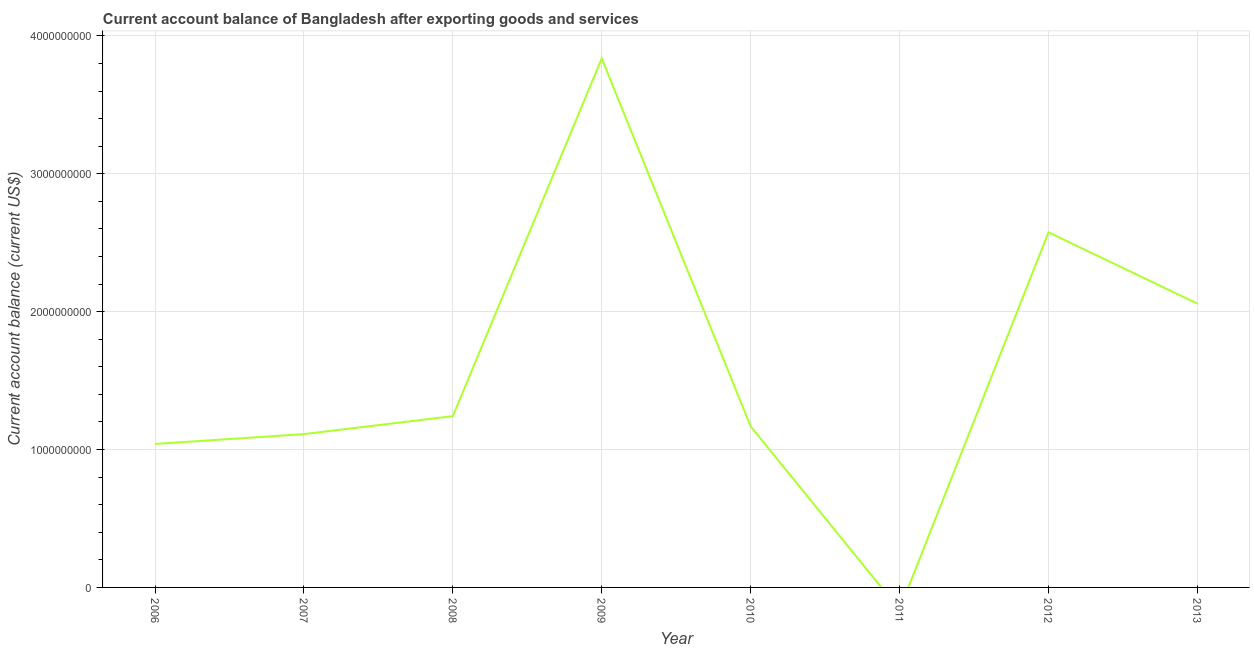What is the current account balance in 2012?
Your answer should be compact. 2.58e+09. Across all years, what is the maximum current account balance?
Offer a very short reply. 3.84e+09. What is the sum of the current account balance?
Your answer should be very brief. 1.30e+1. What is the difference between the current account balance in 2006 and 2009?
Make the answer very short. -2.80e+09. What is the average current account balance per year?
Offer a very short reply. 1.63e+09. What is the median current account balance?
Provide a short and direct response. 1.21e+09. What is the ratio of the current account balance in 2006 to that in 2010?
Your response must be concise. 0.89. What is the difference between the highest and the second highest current account balance?
Provide a short and direct response. 1.26e+09. What is the difference between the highest and the lowest current account balance?
Your answer should be very brief. 3.84e+09. How many lines are there?
Offer a very short reply. 1. Are the values on the major ticks of Y-axis written in scientific E-notation?
Give a very brief answer. No. Does the graph contain grids?
Ensure brevity in your answer.  Yes. What is the title of the graph?
Your answer should be compact. Current account balance of Bangladesh after exporting goods and services. What is the label or title of the X-axis?
Your answer should be very brief. Year. What is the label or title of the Y-axis?
Make the answer very short. Current account balance (current US$). What is the Current account balance (current US$) of 2006?
Keep it short and to the point. 1.04e+09. What is the Current account balance (current US$) in 2007?
Provide a short and direct response. 1.11e+09. What is the Current account balance (current US$) in 2008?
Give a very brief answer. 1.24e+09. What is the Current account balance (current US$) of 2009?
Keep it short and to the point. 3.84e+09. What is the Current account balance (current US$) of 2010?
Ensure brevity in your answer.  1.17e+09. What is the Current account balance (current US$) of 2011?
Make the answer very short. 0. What is the Current account balance (current US$) in 2012?
Keep it short and to the point. 2.58e+09. What is the Current account balance (current US$) in 2013?
Your answer should be compact. 2.06e+09. What is the difference between the Current account balance (current US$) in 2006 and 2007?
Your response must be concise. -7.13e+07. What is the difference between the Current account balance (current US$) in 2006 and 2008?
Give a very brief answer. -2.02e+08. What is the difference between the Current account balance (current US$) in 2006 and 2009?
Give a very brief answer. -2.80e+09. What is the difference between the Current account balance (current US$) in 2006 and 2010?
Provide a succinct answer. -1.27e+08. What is the difference between the Current account balance (current US$) in 2006 and 2012?
Offer a very short reply. -1.53e+09. What is the difference between the Current account balance (current US$) in 2006 and 2013?
Offer a terse response. -1.02e+09. What is the difference between the Current account balance (current US$) in 2007 and 2008?
Keep it short and to the point. -1.30e+08. What is the difference between the Current account balance (current US$) in 2007 and 2009?
Ensure brevity in your answer.  -2.72e+09. What is the difference between the Current account balance (current US$) in 2007 and 2010?
Provide a succinct answer. -5.61e+07. What is the difference between the Current account balance (current US$) in 2007 and 2012?
Offer a very short reply. -1.46e+09. What is the difference between the Current account balance (current US$) in 2007 and 2013?
Give a very brief answer. -9.47e+08. What is the difference between the Current account balance (current US$) in 2008 and 2009?
Make the answer very short. -2.59e+09. What is the difference between the Current account balance (current US$) in 2008 and 2010?
Ensure brevity in your answer.  7.42e+07. What is the difference between the Current account balance (current US$) in 2008 and 2012?
Your answer should be very brief. -1.33e+09. What is the difference between the Current account balance (current US$) in 2008 and 2013?
Give a very brief answer. -8.16e+08. What is the difference between the Current account balance (current US$) in 2009 and 2010?
Give a very brief answer. 2.67e+09. What is the difference between the Current account balance (current US$) in 2009 and 2012?
Offer a terse response. 1.26e+09. What is the difference between the Current account balance (current US$) in 2009 and 2013?
Provide a succinct answer. 1.78e+09. What is the difference between the Current account balance (current US$) in 2010 and 2012?
Make the answer very short. -1.41e+09. What is the difference between the Current account balance (current US$) in 2010 and 2013?
Your answer should be very brief. -8.90e+08. What is the difference between the Current account balance (current US$) in 2012 and 2013?
Give a very brief answer. 5.17e+08. What is the ratio of the Current account balance (current US$) in 2006 to that in 2007?
Keep it short and to the point. 0.94. What is the ratio of the Current account balance (current US$) in 2006 to that in 2008?
Your answer should be very brief. 0.84. What is the ratio of the Current account balance (current US$) in 2006 to that in 2009?
Keep it short and to the point. 0.27. What is the ratio of the Current account balance (current US$) in 2006 to that in 2010?
Give a very brief answer. 0.89. What is the ratio of the Current account balance (current US$) in 2006 to that in 2012?
Your response must be concise. 0.4. What is the ratio of the Current account balance (current US$) in 2006 to that in 2013?
Offer a very short reply. 0.51. What is the ratio of the Current account balance (current US$) in 2007 to that in 2008?
Give a very brief answer. 0.9. What is the ratio of the Current account balance (current US$) in 2007 to that in 2009?
Keep it short and to the point. 0.29. What is the ratio of the Current account balance (current US$) in 2007 to that in 2010?
Give a very brief answer. 0.95. What is the ratio of the Current account balance (current US$) in 2007 to that in 2012?
Your answer should be compact. 0.43. What is the ratio of the Current account balance (current US$) in 2007 to that in 2013?
Keep it short and to the point. 0.54. What is the ratio of the Current account balance (current US$) in 2008 to that in 2009?
Your answer should be compact. 0.32. What is the ratio of the Current account balance (current US$) in 2008 to that in 2010?
Give a very brief answer. 1.06. What is the ratio of the Current account balance (current US$) in 2008 to that in 2012?
Ensure brevity in your answer.  0.48. What is the ratio of the Current account balance (current US$) in 2008 to that in 2013?
Give a very brief answer. 0.6. What is the ratio of the Current account balance (current US$) in 2009 to that in 2010?
Your answer should be very brief. 3.29. What is the ratio of the Current account balance (current US$) in 2009 to that in 2012?
Offer a terse response. 1.49. What is the ratio of the Current account balance (current US$) in 2009 to that in 2013?
Provide a short and direct response. 1.86. What is the ratio of the Current account balance (current US$) in 2010 to that in 2012?
Offer a very short reply. 0.45. What is the ratio of the Current account balance (current US$) in 2010 to that in 2013?
Provide a succinct answer. 0.57. What is the ratio of the Current account balance (current US$) in 2012 to that in 2013?
Offer a terse response. 1.25. 